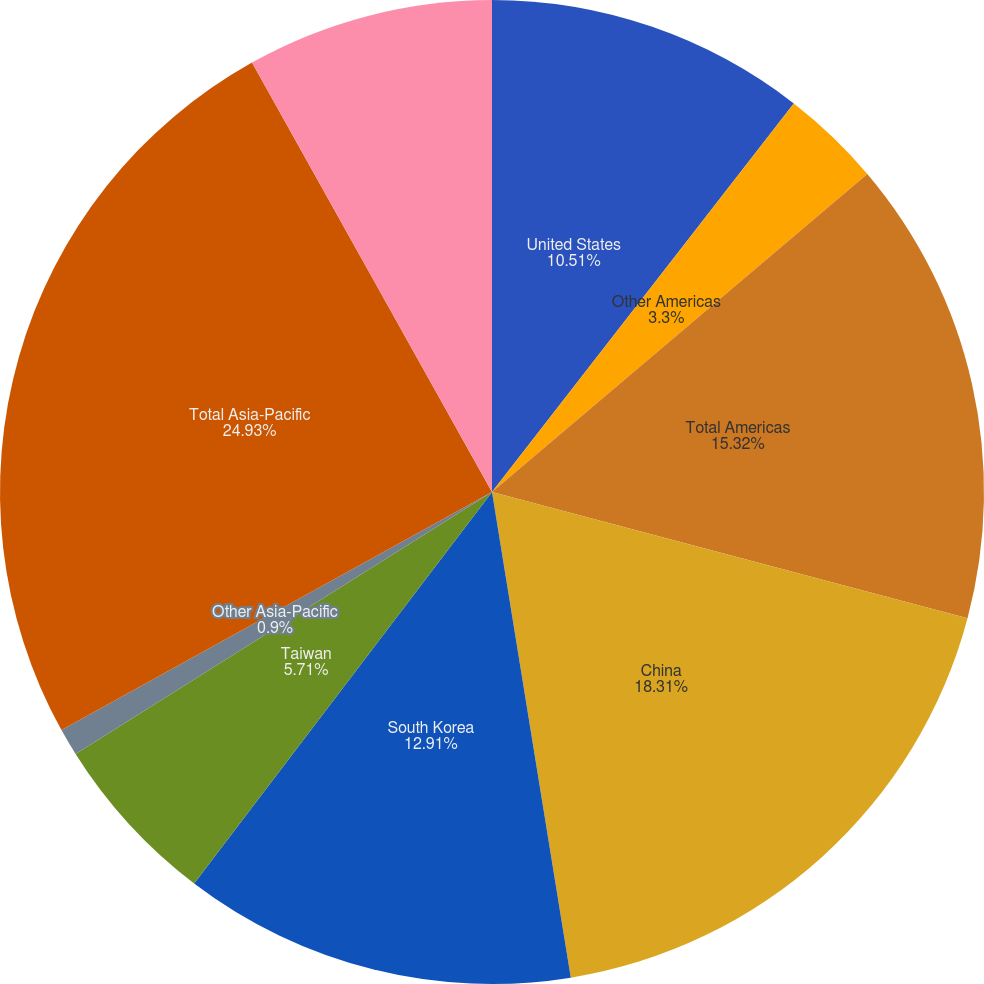Convert chart to OTSL. <chart><loc_0><loc_0><loc_500><loc_500><pie_chart><fcel>United States<fcel>Other Americas<fcel>Total Americas<fcel>China<fcel>South Korea<fcel>Taiwan<fcel>Other Asia-Pacific<fcel>Total Asia-Pacific<fcel>Europe Middle East and Africa<nl><fcel>10.51%<fcel>3.3%<fcel>15.32%<fcel>18.31%<fcel>12.91%<fcel>5.71%<fcel>0.9%<fcel>24.93%<fcel>8.11%<nl></chart> 